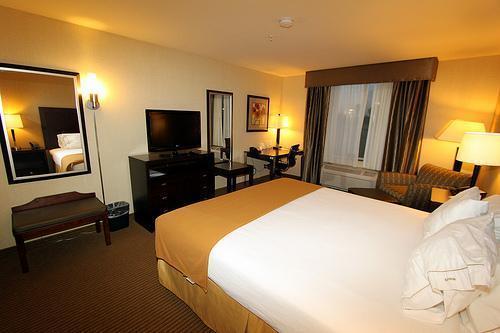How many beds are there?
Give a very brief answer. 1. How many lamps are attached to the wall in this image?
Give a very brief answer. 1. 